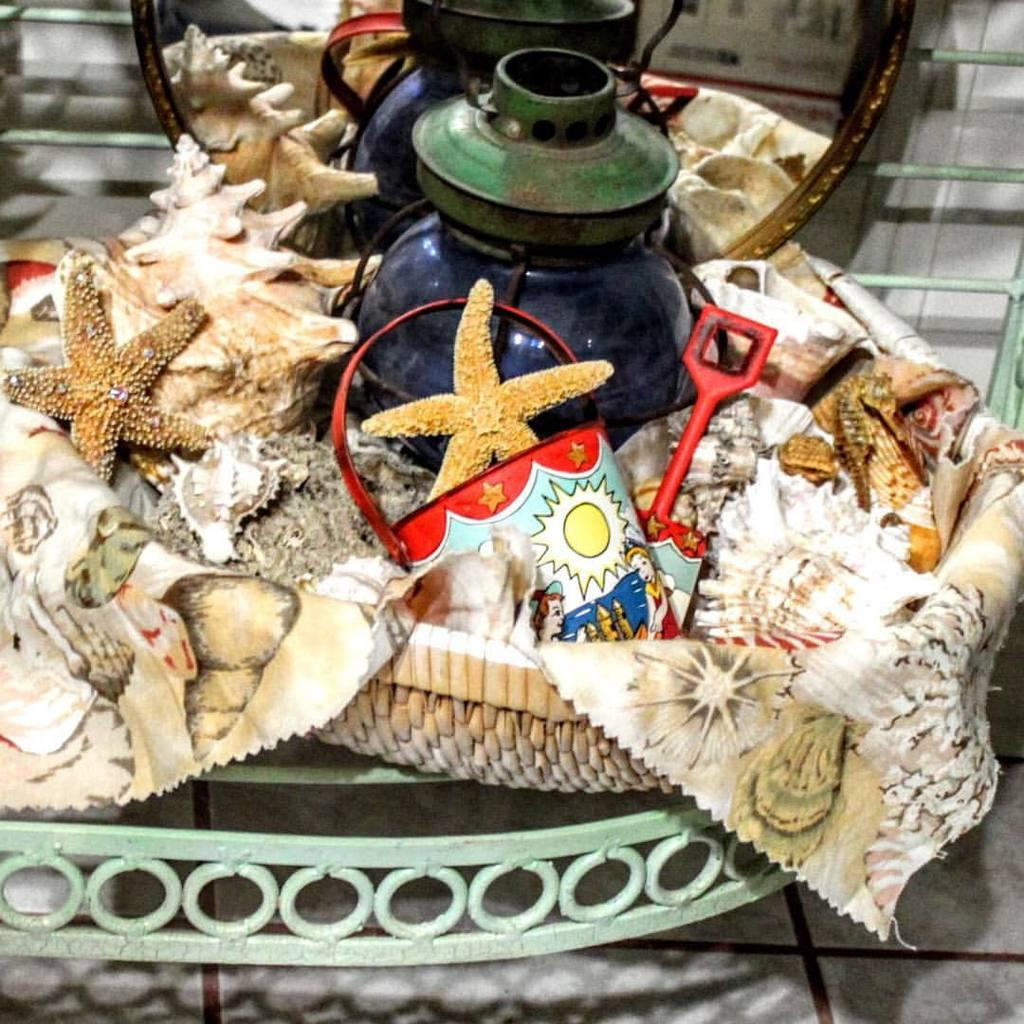What type of object can be seen in the image? There is a tire, a lamp, a bucket, and a cloth visible in the image. What is the purpose of the objects in the basket? The purpose of the objects in the basket is not clear from the image, but they are visible. How is the basket supported in the image? The basket is placed on a metal frame in the image. What type of structure is visible in the image? There are metal poles and a wall visible in the image. What grade does the representative animal in the image receive for its performance? There is no representative animal present in the image, so it is not possible to determine its performance or grade. 